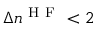Convert formula to latex. <formula><loc_0><loc_0><loc_500><loc_500>\Delta n ^ { H F } < 2</formula> 